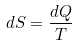<formula> <loc_0><loc_0><loc_500><loc_500>d S = \frac { d Q } { T }</formula> 